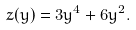Convert formula to latex. <formula><loc_0><loc_0><loc_500><loc_500>z ( y ) = 3 y ^ { 4 } + 6 y ^ { 2 } .</formula> 